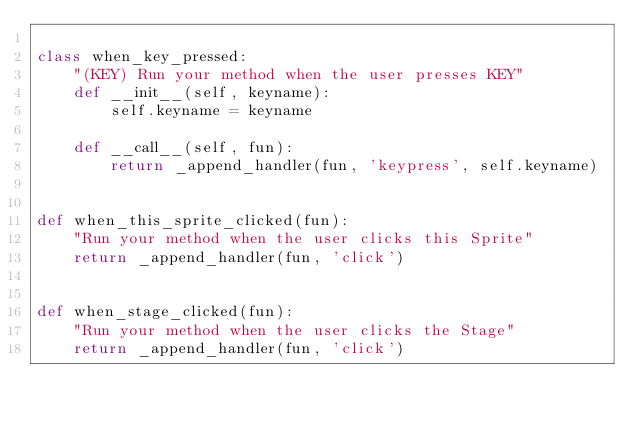<code> <loc_0><loc_0><loc_500><loc_500><_Python_>
class when_key_pressed:
    "(KEY) Run your method when the user presses KEY"
    def __init__(self, keyname):
        self.keyname = keyname

    def __call__(self, fun):
        return _append_handler(fun, 'keypress', self.keyname)


def when_this_sprite_clicked(fun):
    "Run your method when the user clicks this Sprite"
    return _append_handler(fun, 'click')


def when_stage_clicked(fun):
    "Run your method when the user clicks the Stage"
    return _append_handler(fun, 'click')
</code> 